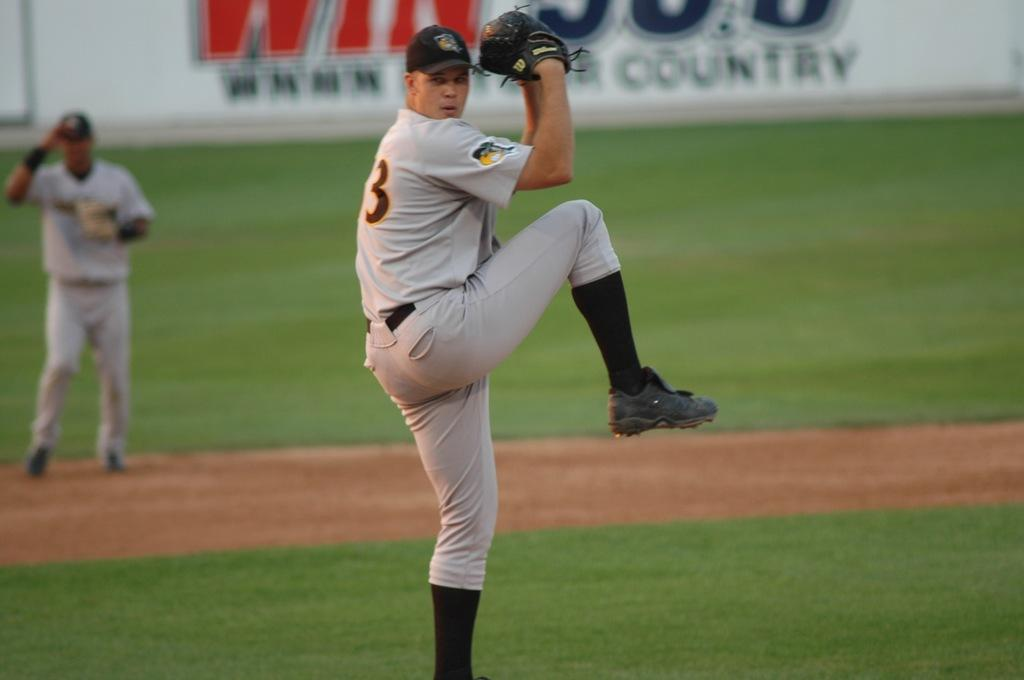<image>
Provide a brief description of the given image. A baseball pitcher wearing a number 3 uniform is using a Wilson glove. 